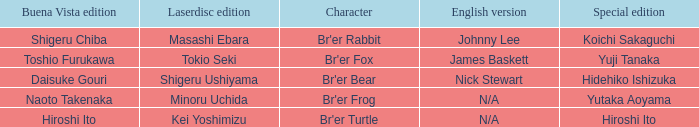Who is the buena vista edidtion where special edition is koichi sakaguchi? Shigeru Chiba. Parse the full table. {'header': ['Buena Vista edition', 'Laserdisc edition', 'Character', 'English version', 'Special edition'], 'rows': [['Shigeru Chiba', 'Masashi Ebara', "Br'er Rabbit", 'Johnny Lee', 'Koichi Sakaguchi'], ['Toshio Furukawa', 'Tokio Seki', "Br'er Fox", 'James Baskett', 'Yuji Tanaka'], ['Daisuke Gouri', 'Shigeru Ushiyama', "Br'er Bear", 'Nick Stewart', 'Hidehiko Ishizuka'], ['Naoto Takenaka', 'Minoru Uchida', "Br'er Frog", 'N/A', 'Yutaka Aoyama'], ['Hiroshi Ito', 'Kei Yoshimizu', "Br'er Turtle", 'N/A', 'Hiroshi Ito']]} 